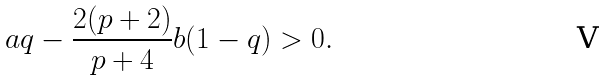Convert formula to latex. <formula><loc_0><loc_0><loc_500><loc_500>a q - \frac { 2 ( p + 2 ) } { p + 4 } b ( 1 - q ) > 0 .</formula> 